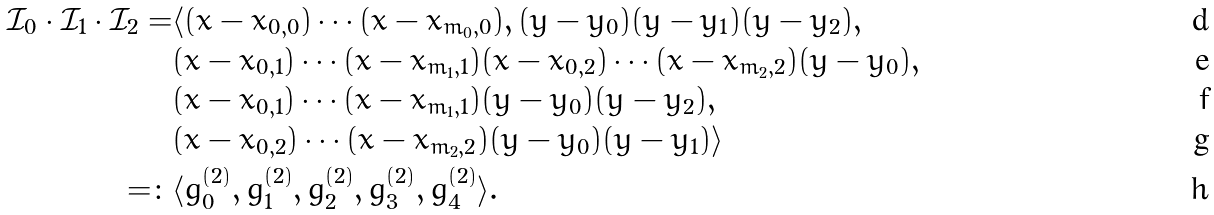<formula> <loc_0><loc_0><loc_500><loc_500>\mathcal { I } _ { 0 } \cdot \mathcal { I } _ { 1 } \cdot \mathcal { I } _ { 2 } = & \langle ( x - x _ { 0 , 0 } ) \cdots ( x - x _ { m _ { 0 } , 0 } ) , ( y - y _ { 0 } ) ( y - y _ { 1 } ) ( y - y _ { 2 } ) , \\ & ( x - x _ { 0 , 1 } ) \cdots ( x - x _ { m _ { 1 } , 1 } ) ( x - x _ { 0 , 2 } ) \cdots ( x - x _ { m _ { 2 } , 2 } ) ( y - y _ { 0 } ) , \\ & ( x - x _ { 0 , 1 } ) \cdots ( x - x _ { m _ { 1 } , 1 } ) ( y - y _ { 0 } ) ( y - y _ { 2 } ) , \\ & ( x - x _ { 0 , 2 } ) \cdots ( x - x _ { m _ { 2 } , 2 } ) ( y - y _ { 0 } ) ( y - y _ { 1 } ) \rangle \\ = \colon & \langle g _ { 0 } ^ { ( 2 ) } , g _ { 1 } ^ { ( 2 ) } , g _ { 2 } ^ { ( 2 ) } , g _ { 3 } ^ { ( 2 ) } , g _ { 4 } ^ { ( 2 ) } \rangle .</formula> 